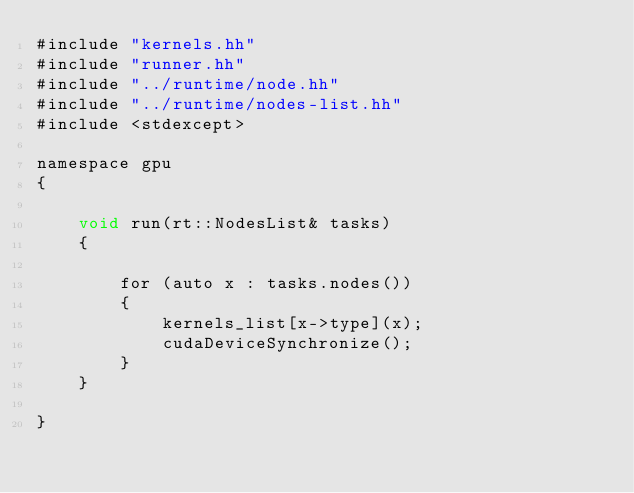Convert code to text. <code><loc_0><loc_0><loc_500><loc_500><_Cuda_>#include "kernels.hh"
#include "runner.hh"
#include "../runtime/node.hh"
#include "../runtime/nodes-list.hh"
#include <stdexcept>

namespace gpu
{

    void run(rt::NodesList& tasks)
    {

        for (auto x : tasks.nodes())
        {
            kernels_list[x->type](x);
            cudaDeviceSynchronize();
        }
    }
    
}
</code> 